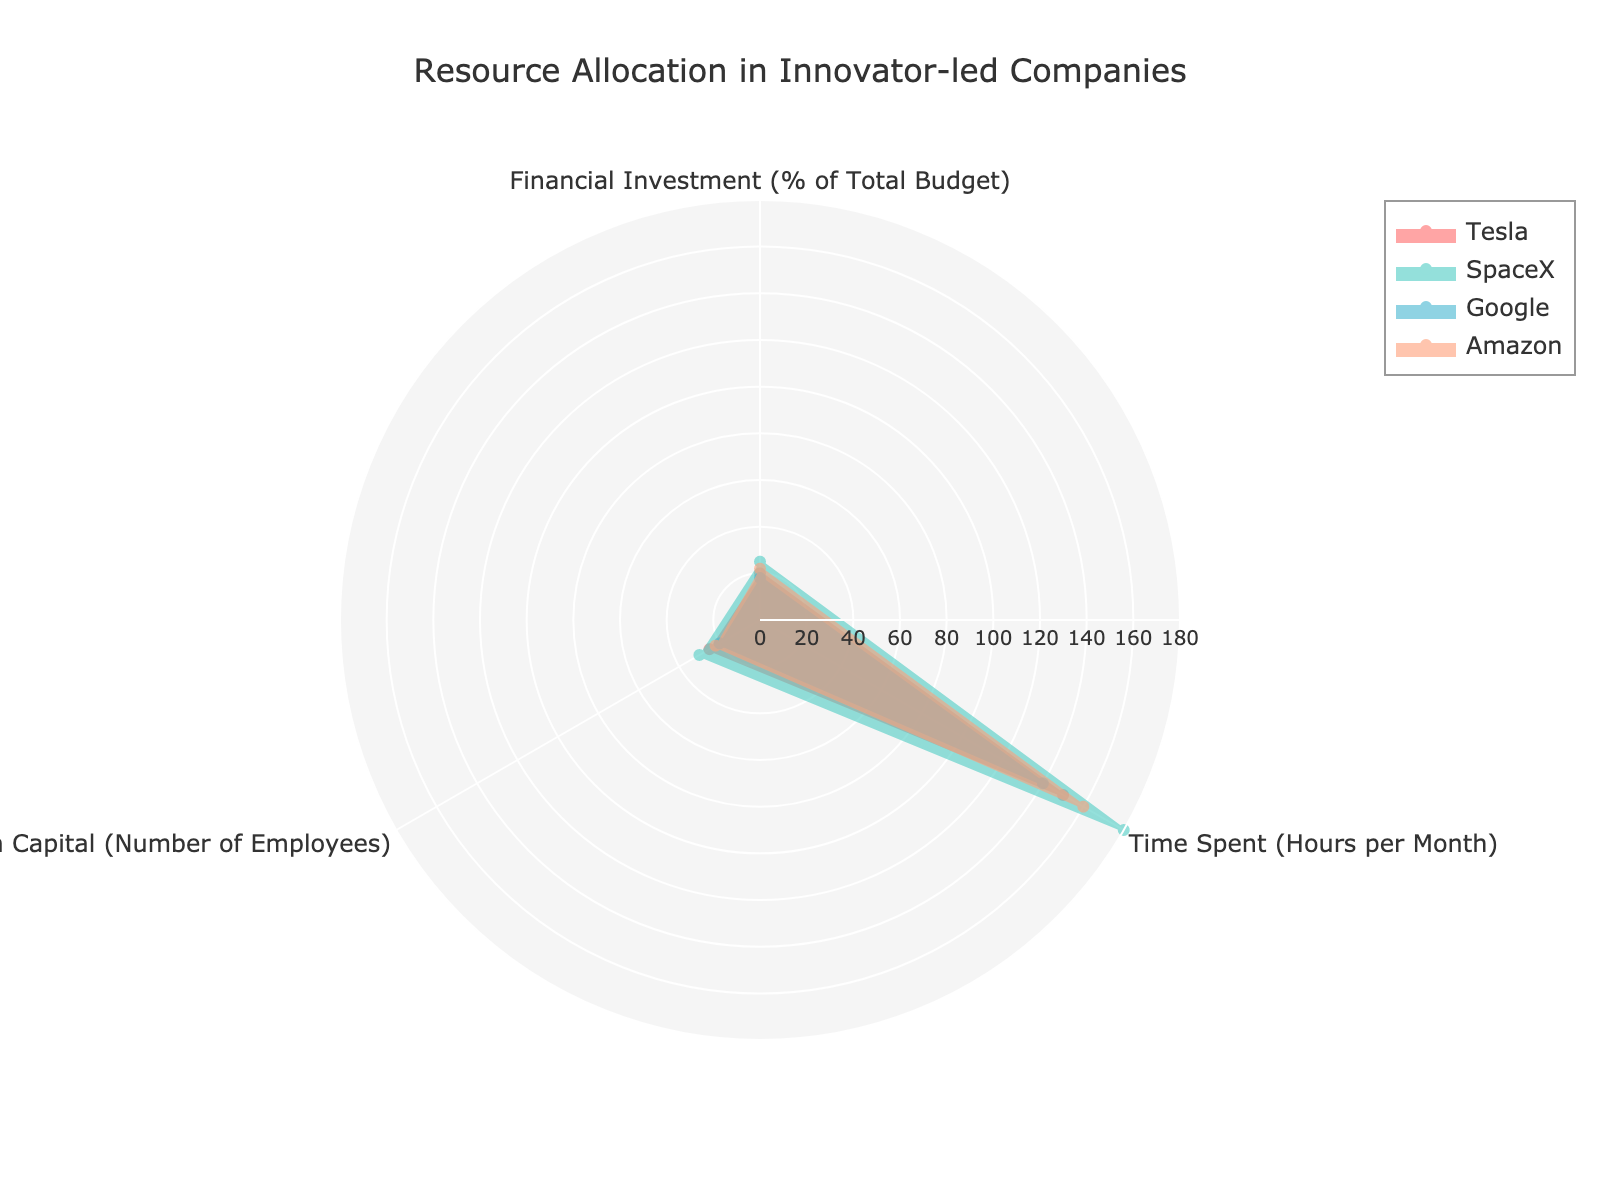What's the title of the chart? The title is usually placed at the top of the chart for easy recognition. In this case, it's fairly straightforward to find since it's mentioned directly in the layout description.
Answer: Resource Allocation in Innovator-led Companies How many groups are compared in the chart? By looking at the chart, we can see four distinct data lines, each representing a different company or group. Each group is identifiable by a unique color and the legend that labels them.
Answer: 4 Which group has the highest financial investment? Reviewing the section of the chart dedicated to Financial Investment, we observe that SpaceX reaches the highest point on the radial axis in that category.
Answer: SpaceX What is the range of radial values shown on the chart? The range of radial values is determined by the highest value among all categories and groups, and as set by the axis configuration. The maximum investment percentage, hours per month, and employee number are all visible in the chart.
Answer: 0 to 180 Which category has the largest difference between the top and the bottom group? We'll examine each category and find the difference between the highest and lowest values. Financial Investment: SpaceX 25% to Google 18% (difference 7%), Time Spent: SpaceX 180 to Google 140 (difference 40), Human Capital: SpaceX 30 to Google 20 (difference 10). The largest difference is in Time Spent.
Answer: Time Spent How does Amazon compare to Tesla in terms of Human Capital? By locating the Human Capital values for Amazon and Tesla on the chart, we can compare their respective positions along the radial axis. Both groups have their values marked by distinct colors.
Answer: Amazon has 22 employees and Tesla has 25 employees If you were to order the groups from highest to lowest based on Time Spent, what would that order be? By examining the radial axis associated with Time Spent and noting the respective positions for each group, we can order them. SpaceX has the highest at 180, followed by Amazon at 160, Tesla at 150, and Google at 140.
Answer: SpaceX, Amazon, Tesla, Google What's the average number of hours spent monthly on training across all groups? Add the hours spent on training for each group: SpaceX (180), Tesla (150), Amazon (160), Google (140). Then divide by 4 to find the average: (180 + 150 + 160 + 140) / 4 = 157.5.
Answer: 157.5 Which group allocates the least financial investment in training? The Financial Investment category shows that Google, with a lower value compared to the others, allocates the least.
Answer: Google What's the sum of Financial Investments for all groups? Summing the Financial Investment percentages from the chart: Tesla (20%), SpaceX (25%), Google (18%), Amazon (22%). The total is 20 + 25 + 18 + 22 = 85%.
Answer: 85% 